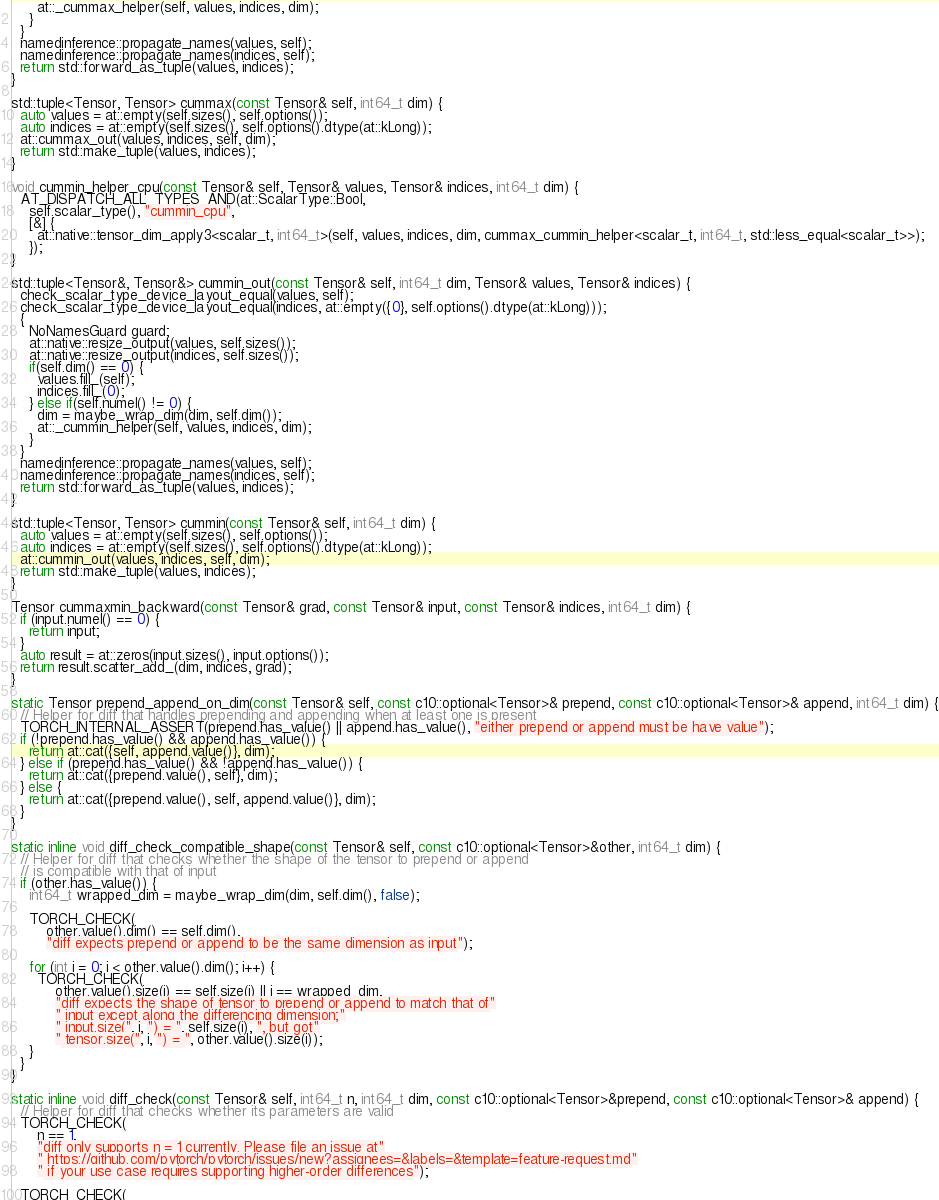Convert code to text. <code><loc_0><loc_0><loc_500><loc_500><_C++_>      at::_cummax_helper(self, values, indices, dim);
    }
  }
  namedinference::propagate_names(values, self);
  namedinference::propagate_names(indices, self);
  return std::forward_as_tuple(values, indices);
}

std::tuple<Tensor, Tensor> cummax(const Tensor& self, int64_t dim) {
  auto values = at::empty(self.sizes(), self.options());
  auto indices = at::empty(self.sizes(), self.options().dtype(at::kLong));
  at::cummax_out(values, indices, self, dim);
  return std::make_tuple(values, indices);
}

void cummin_helper_cpu(const Tensor& self, Tensor& values, Tensor& indices, int64_t dim) {
  AT_DISPATCH_ALL_TYPES_AND(at::ScalarType::Bool,
    self.scalar_type(), "cummin_cpu",
    [&] {
      at::native::tensor_dim_apply3<scalar_t, int64_t>(self, values, indices, dim, cummax_cummin_helper<scalar_t, int64_t, std::less_equal<scalar_t>>);
    });
}

std::tuple<Tensor&, Tensor&> cummin_out(const Tensor& self, int64_t dim, Tensor& values, Tensor& indices) {
  check_scalar_type_device_layout_equal(values, self);
  check_scalar_type_device_layout_equal(indices, at::empty({0}, self.options().dtype(at::kLong)));
  {
    NoNamesGuard guard;
    at::native::resize_output(values, self.sizes());
    at::native::resize_output(indices, self.sizes());
    if(self.dim() == 0) {
      values.fill_(self);
      indices.fill_(0);
    } else if(self.numel() != 0) {
      dim = maybe_wrap_dim(dim, self.dim());
      at::_cummin_helper(self, values, indices, dim);
    }
  }
  namedinference::propagate_names(values, self);
  namedinference::propagate_names(indices, self);
  return std::forward_as_tuple(values, indices);
}

std::tuple<Tensor, Tensor> cummin(const Tensor& self, int64_t dim) {
  auto values = at::empty(self.sizes(), self.options());
  auto indices = at::empty(self.sizes(), self.options().dtype(at::kLong));
  at::cummin_out(values, indices, self, dim);
  return std::make_tuple(values, indices);
}

Tensor cummaxmin_backward(const Tensor& grad, const Tensor& input, const Tensor& indices, int64_t dim) {
  if (input.numel() == 0) {
    return input;
  }
  auto result = at::zeros(input.sizes(), input.options());
  return result.scatter_add_(dim, indices, grad);
}

static Tensor prepend_append_on_dim(const Tensor& self, const c10::optional<Tensor>& prepend, const c10::optional<Tensor>& append, int64_t dim) {
  // Helper for diff that handles prepending and appending when at least one is present
  TORCH_INTERNAL_ASSERT(prepend.has_value() || append.has_value(), "either prepend or append must be have value");
  if (!prepend.has_value() && append.has_value()) {
    return at::cat({self, append.value()}, dim);
  } else if (prepend.has_value() && !append.has_value()) {
    return at::cat({prepend.value(), self}, dim);
  } else {
    return at::cat({prepend.value(), self, append.value()}, dim);
  }
}

static inline void diff_check_compatible_shape(const Tensor& self, const c10::optional<Tensor>&other, int64_t dim) {
  // Helper for diff that checks whether the shape of the tensor to prepend or append
  // is compatible with that of input
  if (other.has_value()) {
    int64_t wrapped_dim = maybe_wrap_dim(dim, self.dim(), false);

    TORCH_CHECK(
        other.value().dim() == self.dim(),
        "diff expects prepend or append to be the same dimension as input");

    for (int i = 0; i < other.value().dim(); i++) {
      TORCH_CHECK(
          other.value().size(i) == self.size(i) || i == wrapped_dim,
          "diff expects the shape of tensor to prepend or append to match that of"
          " input except along the differencing dimension;"
          " input.size(", i, ") = ", self.size(i), ", but got"
          " tensor.size(", i, ") = ", other.value().size(i));
    }
  }
}

static inline void diff_check(const Tensor& self, int64_t n, int64_t dim, const c10::optional<Tensor>&prepend, const c10::optional<Tensor>& append) {
  // Helper for diff that checks whether its parameters are valid
  TORCH_CHECK(
      n == 1,
      "diff only supports n = 1 currently. Please file an issue at"
      " https://github.com/pytorch/pytorch/issues/new?assignees=&labels=&template=feature-request.md"
      " if your use case requires supporting higher-order differences");

  TORCH_CHECK(</code> 